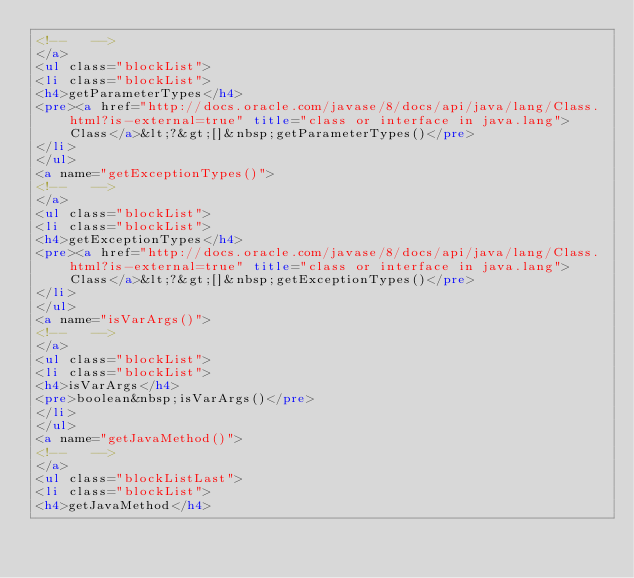<code> <loc_0><loc_0><loc_500><loc_500><_HTML_><!--   -->
</a>
<ul class="blockList">
<li class="blockList">
<h4>getParameterTypes</h4>
<pre><a href="http://docs.oracle.com/javase/8/docs/api/java/lang/Class.html?is-external=true" title="class or interface in java.lang">Class</a>&lt;?&gt;[]&nbsp;getParameterTypes()</pre>
</li>
</ul>
<a name="getExceptionTypes()">
<!--   -->
</a>
<ul class="blockList">
<li class="blockList">
<h4>getExceptionTypes</h4>
<pre><a href="http://docs.oracle.com/javase/8/docs/api/java/lang/Class.html?is-external=true" title="class or interface in java.lang">Class</a>&lt;?&gt;[]&nbsp;getExceptionTypes()</pre>
</li>
</ul>
<a name="isVarArgs()">
<!--   -->
</a>
<ul class="blockList">
<li class="blockList">
<h4>isVarArgs</h4>
<pre>boolean&nbsp;isVarArgs()</pre>
</li>
</ul>
<a name="getJavaMethod()">
<!--   -->
</a>
<ul class="blockListLast">
<li class="blockList">
<h4>getJavaMethod</h4></code> 